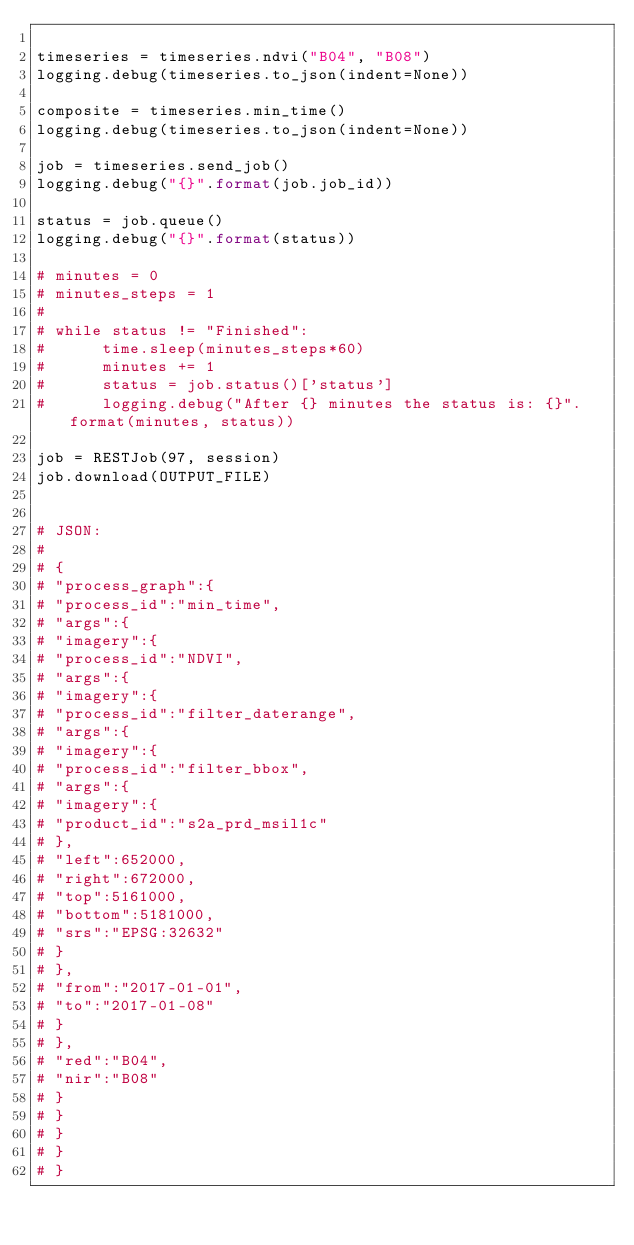Convert code to text. <code><loc_0><loc_0><loc_500><loc_500><_Python_>
timeseries = timeseries.ndvi("B04", "B08")
logging.debug(timeseries.to_json(indent=None))

composite = timeseries.min_time()
logging.debug(timeseries.to_json(indent=None))

job = timeseries.send_job()
logging.debug("{}".format(job.job_id))

status = job.queue()
logging.debug("{}".format(status))

# minutes = 0
# minutes_steps = 1
#
# while status != "Finished":
#      time.sleep(minutes_steps*60)
#      minutes += 1
#      status = job.status()['status']
#      logging.debug("After {} minutes the status is: {}".format(minutes, status))

job = RESTJob(97, session)
job.download(OUTPUT_FILE)


# JSON:
#
# {
# "process_graph":{
# "process_id":"min_time",
# "args":{
# "imagery":{
# "process_id":"NDVI",
# "args":{
# "imagery":{
# "process_id":"filter_daterange",
# "args":{
# "imagery":{
# "process_id":"filter_bbox",
# "args":{
# "imagery":{
# "product_id":"s2a_prd_msil1c"
# },
# "left":652000,
# "right":672000,
# "top":5161000,
# "bottom":5181000,
# "srs":"EPSG:32632"
# }
# },
# "from":"2017-01-01",
# "to":"2017-01-08"
# }
# },
# "red":"B04",
# "nir":"B08"
# }
# }
# }
# }
# }
</code> 